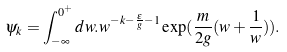Convert formula to latex. <formula><loc_0><loc_0><loc_500><loc_500>\psi _ { k } = \int _ { - \infty } ^ { 0 ^ { + } } d w . w ^ { - k - \frac { \epsilon } { g } - 1 } \exp ( \frac { m } { 2 g } ( w + \frac { 1 } { w } ) ) .</formula> 